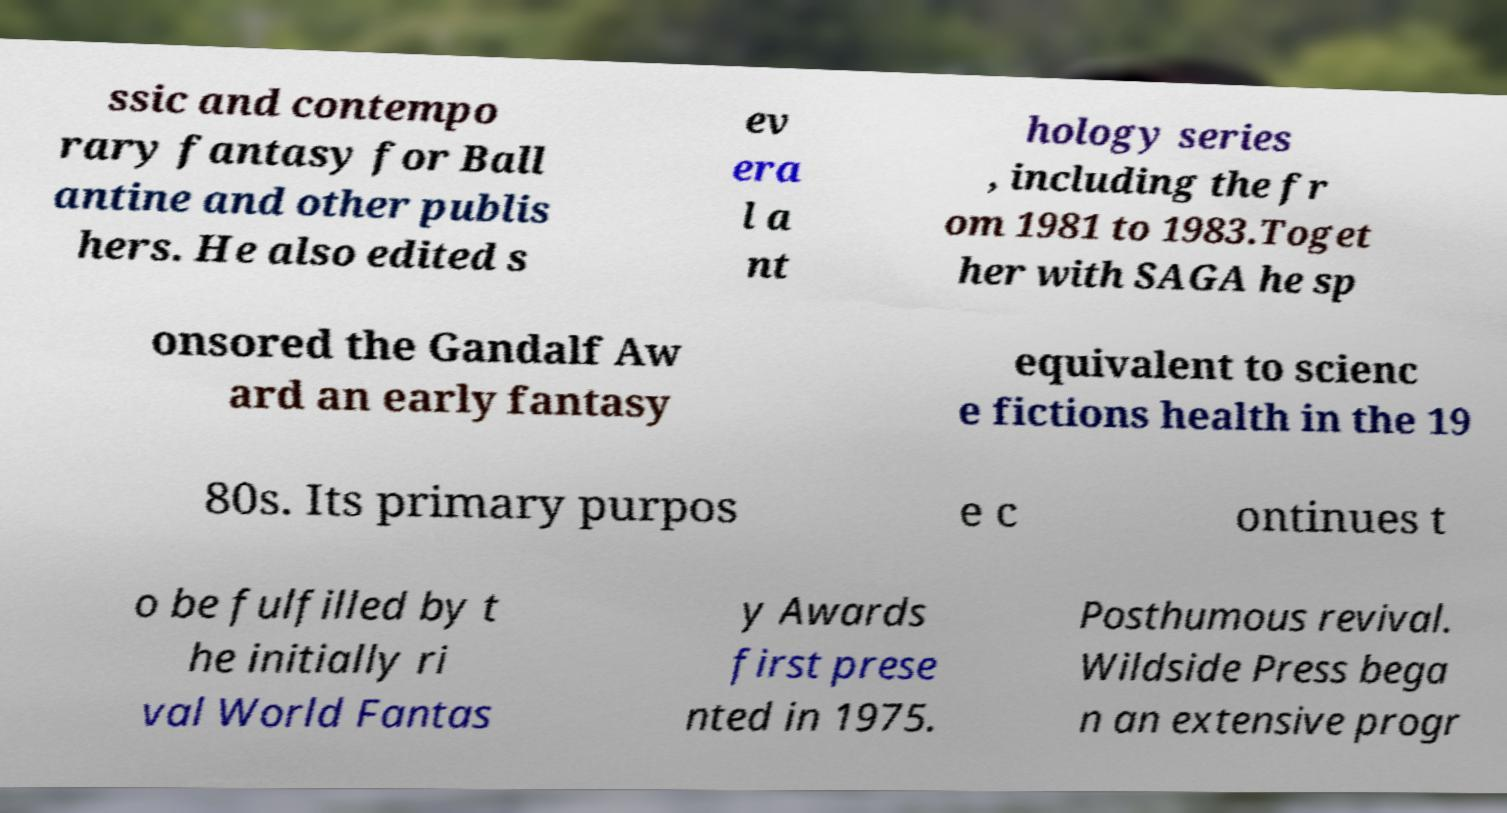Please read and relay the text visible in this image. What does it say? ssic and contempo rary fantasy for Ball antine and other publis hers. He also edited s ev era l a nt hology series , including the fr om 1981 to 1983.Toget her with SAGA he sp onsored the Gandalf Aw ard an early fantasy equivalent to scienc e fictions health in the 19 80s. Its primary purpos e c ontinues t o be fulfilled by t he initially ri val World Fantas y Awards first prese nted in 1975. Posthumous revival. Wildside Press bega n an extensive progr 